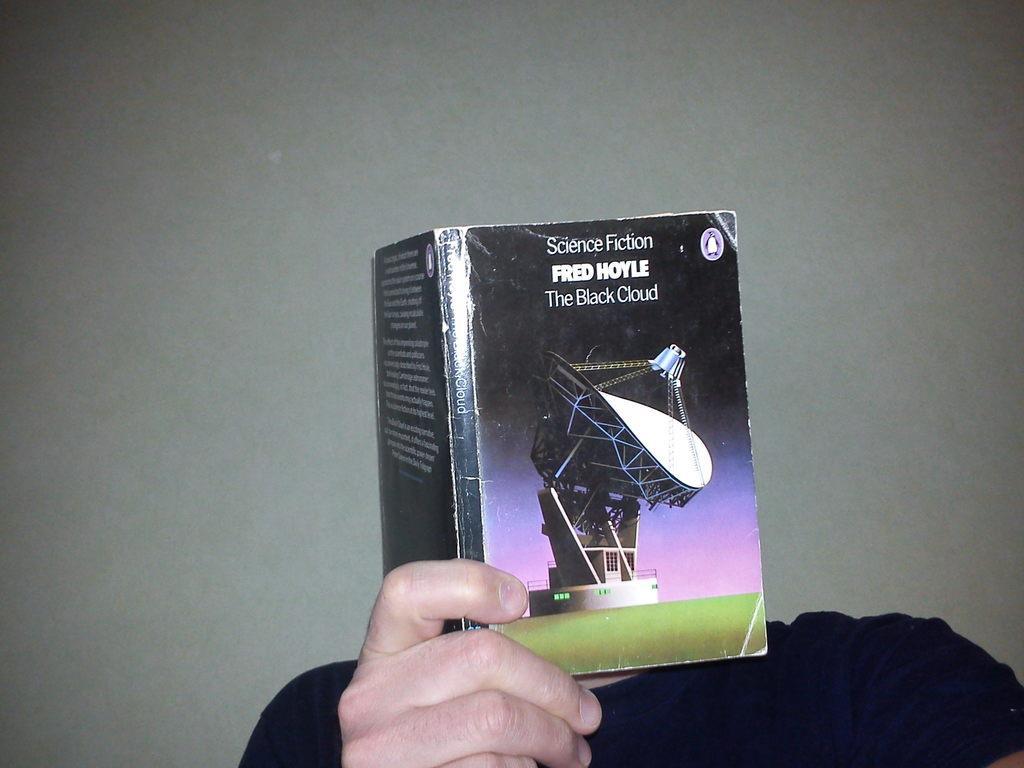In one or two sentences, can you explain what this image depicts? In the center of the image a person is holding a book. In the background of the image a wall is there. 